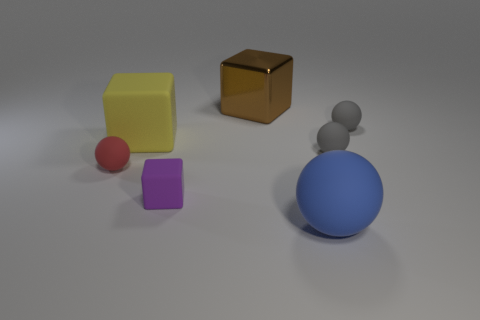Add 2 small red matte things. How many objects exist? 9 Subtract all balls. How many objects are left? 3 Subtract 0 green spheres. How many objects are left? 7 Subtract all large yellow cubes. Subtract all big brown blocks. How many objects are left? 5 Add 3 tiny red matte spheres. How many tiny red matte spheres are left? 4 Add 2 gray rubber things. How many gray rubber things exist? 4 